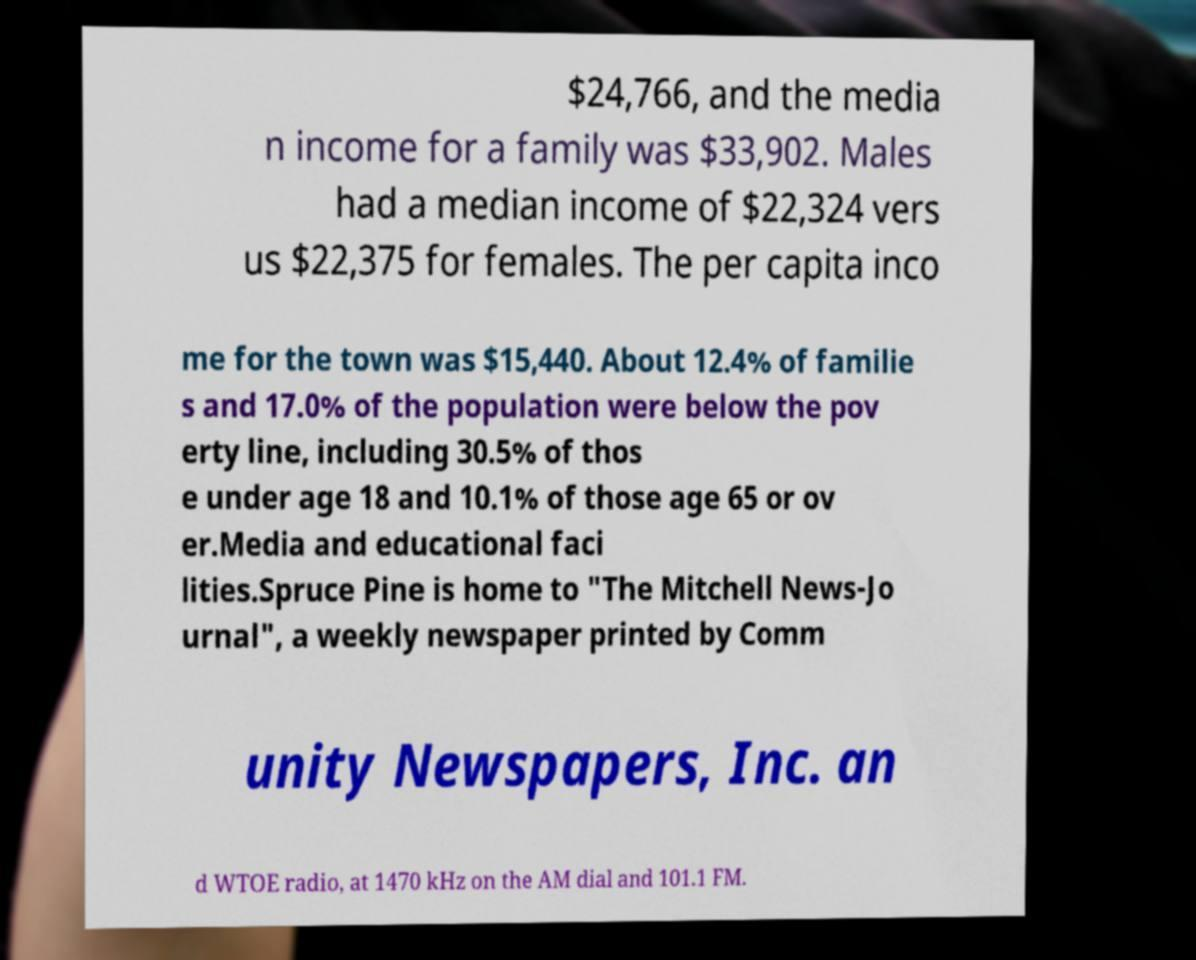For documentation purposes, I need the text within this image transcribed. Could you provide that? $24,766, and the media n income for a family was $33,902. Males had a median income of $22,324 vers us $22,375 for females. The per capita inco me for the town was $15,440. About 12.4% of familie s and 17.0% of the population were below the pov erty line, including 30.5% of thos e under age 18 and 10.1% of those age 65 or ov er.Media and educational faci lities.Spruce Pine is home to "The Mitchell News-Jo urnal", a weekly newspaper printed by Comm unity Newspapers, Inc. an d WTOE radio, at 1470 kHz on the AM dial and 101.1 FM. 